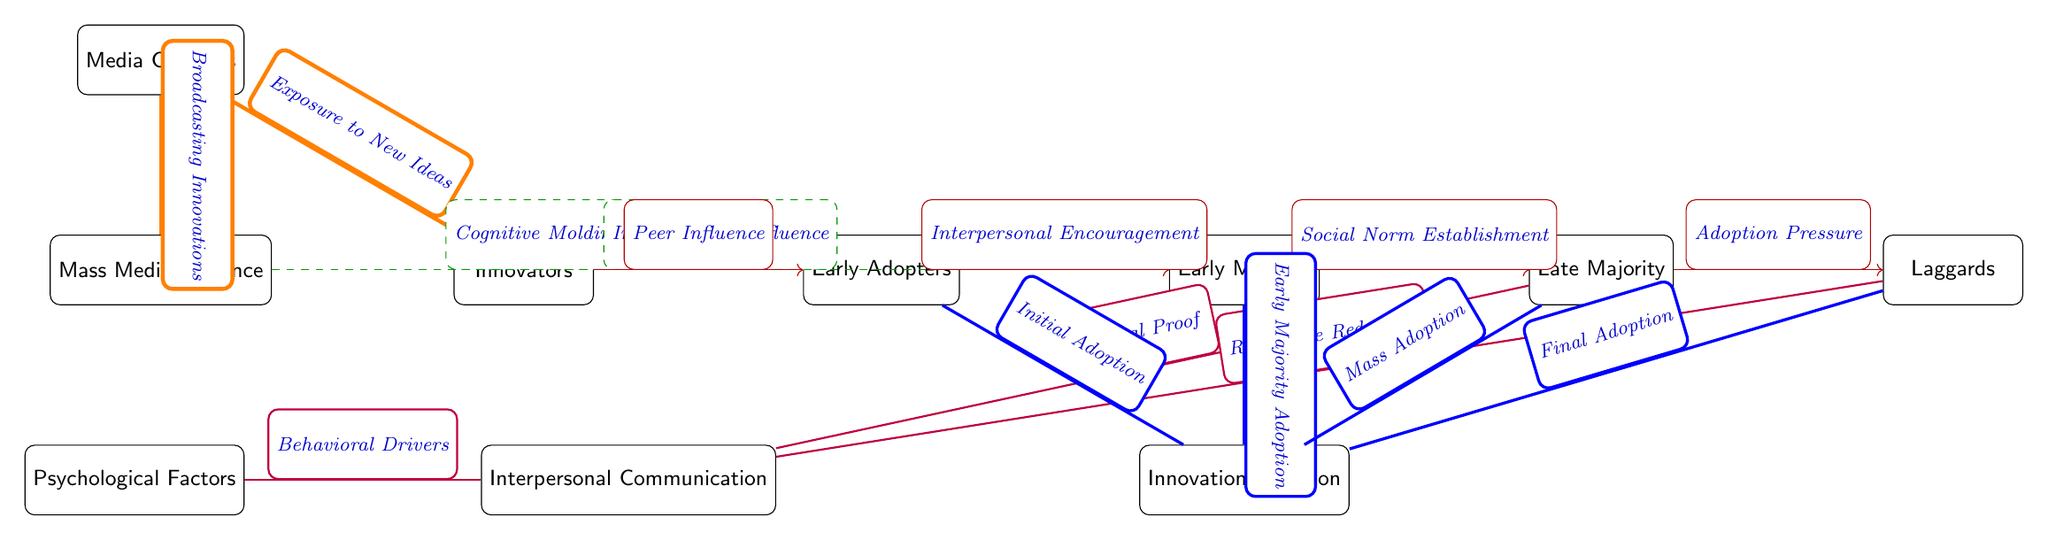What are the nodes in the category of adoption? The nodes that represent different stages of adoption are Innovators, Early Adopters, Early Majority, Late Majority, and Laggards. These nodes are sequentially arranged from left to right in the diagram.
Answer: Innovators, Early Adopters, Early Majority, Late Majority, Laggards How many media-related nodes are present in the diagram? There are three nodes related to media, which are Media Channels, Mass Media Influence, and Interpersonal Communication. These nodes deal with the influence of media on innovation adoption.
Answer: 3 What is the nature of the relationship between Early Majority and Late Majority? The relationship is established through a directed influence, specifically labeled "Social Norm Establishment." This indicates that the Early Majority influences the Late Majority's decision to adopt an innovation within a social context.
Answer: Social Norm Establishment Which nodes represent psychological factors? The node labeled "Psychological Factors" represents the psychological concepts affecting adoption, and it connects to the "Interpersonal Communication" node with a thick purple line indicating their relationship.
Answer: Psychological Factors Which stage of adoption is associated with "Final Adoption"? The "Final Adoption" is associated with the Laggards stage, as indicated by the directed edge from the Laggards node to the Innovation Adoption node. This shows that Laggards are the last to adopt innovations.
Answer: Laggards What influences the transition from Early Adopters to Early Majority? The transition from Early Adopters to Early Majority is influenced by "Interpersonal Encouragement," which signifies the need for support from peers for adoption among the Early Majority.
Answer: Interpersonal Encouragement Identify the influence originating from the node labeled "Mass Media Influence." The influence originating from "Mass Media Influence" impacts both the Early Adopters and the Early Majority, as it carries two arrows indicating that it affects cognitive molding and informational influence on these nodes respectively.
Answer: Cognitive Molding, Informational Influence What represents the flow of innovation adoption towards the final stage? The flow of innovation adoption towards the final stage is represented by the transitions from Innovators to Early Adopters to Early Majority to Late Majority and finally to Laggards, which culminate in Final Adoption. The flow is indicated by a series of directed edges leading to the Innovation Adoption node.
Answer: Innovators to Laggards 